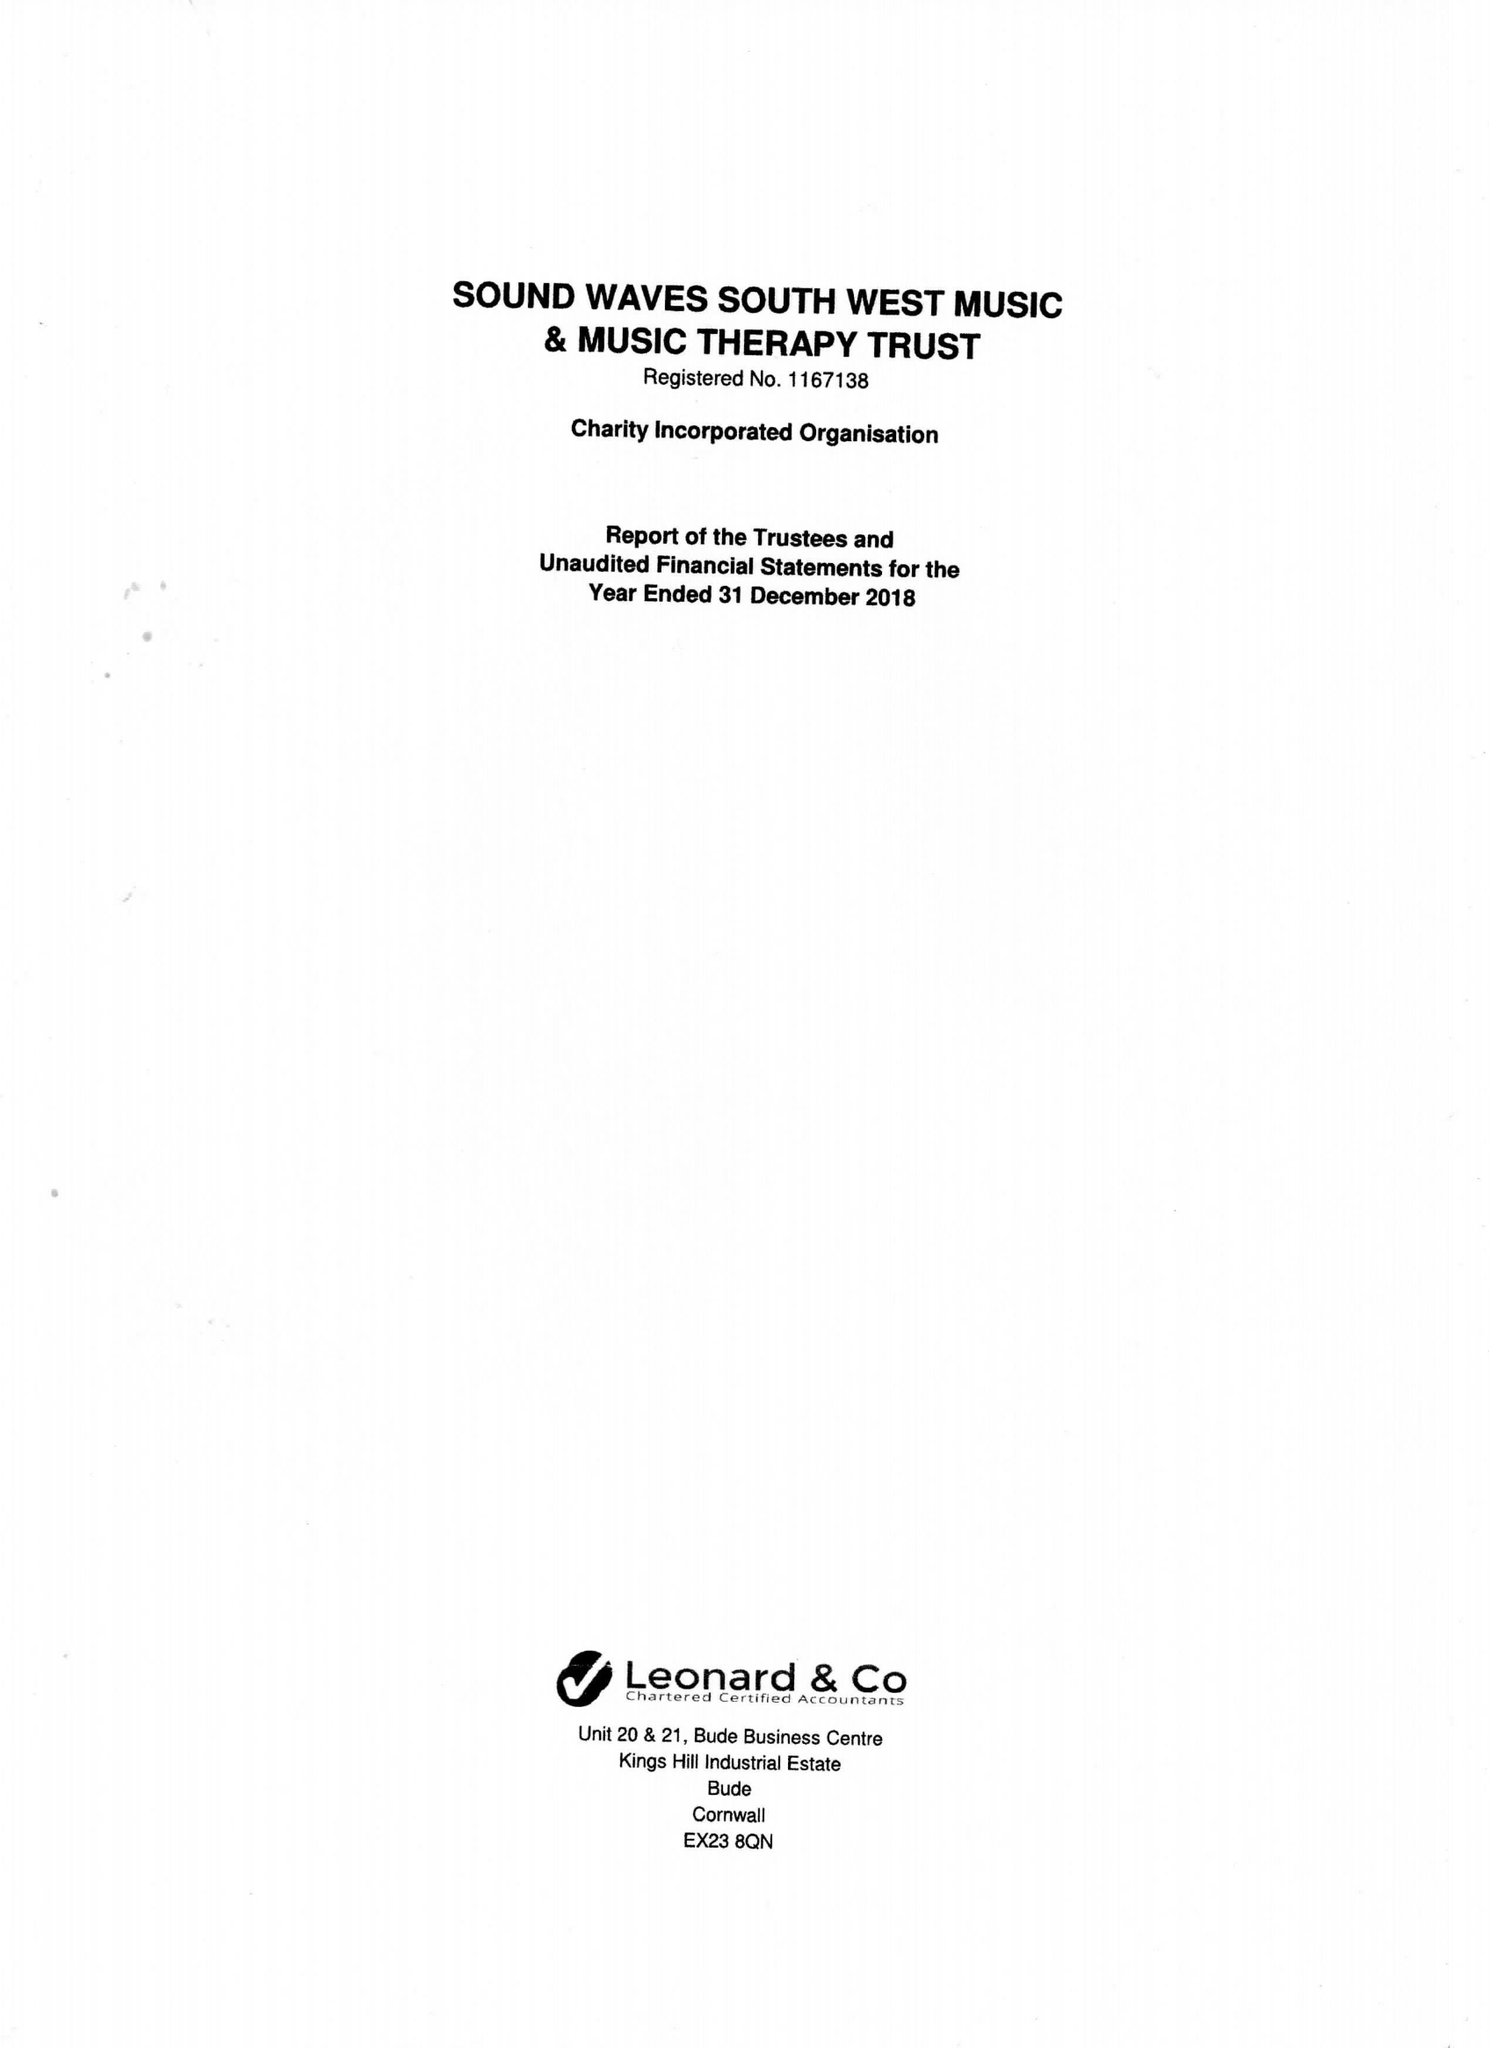What is the value for the charity_name?
Answer the question using a single word or phrase. Sound Waves South West Music and Music Therapy Trust 